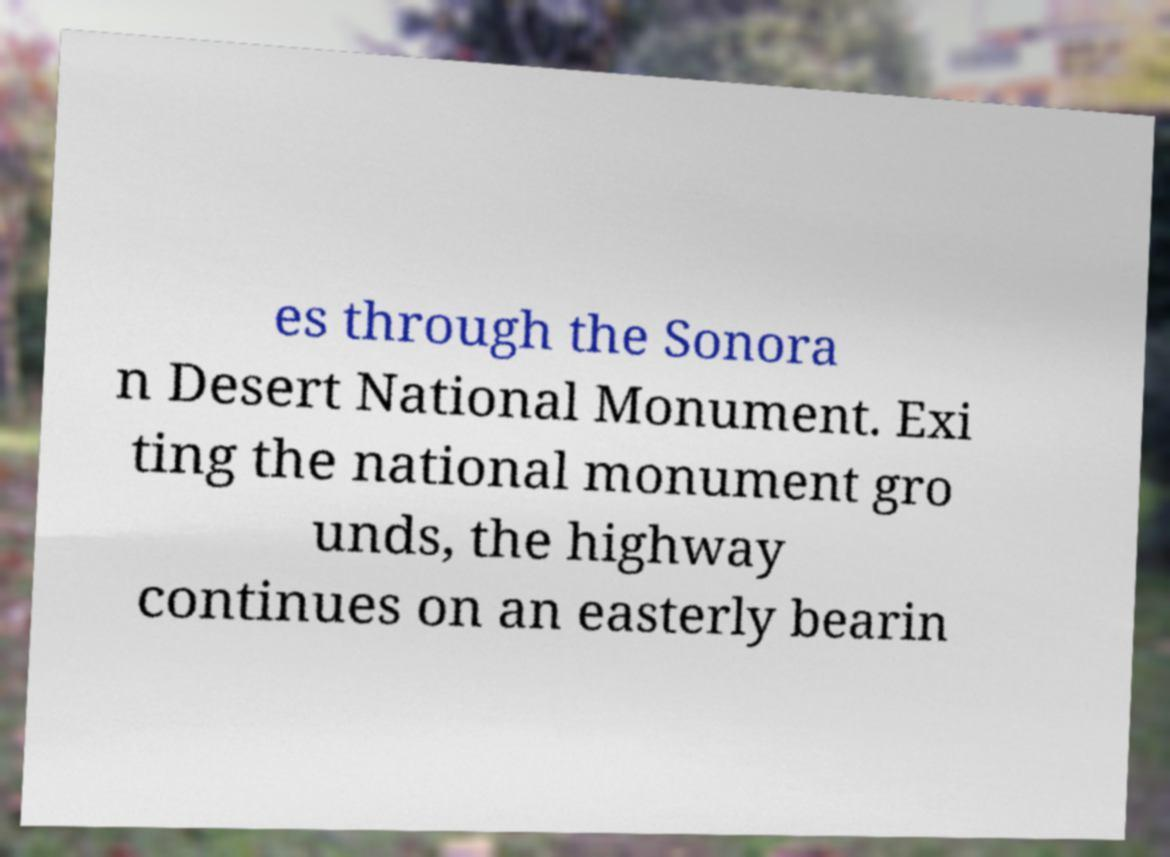What messages or text are displayed in this image? I need them in a readable, typed format. es through the Sonora n Desert National Monument. Exi ting the national monument gro unds, the highway continues on an easterly bearin 